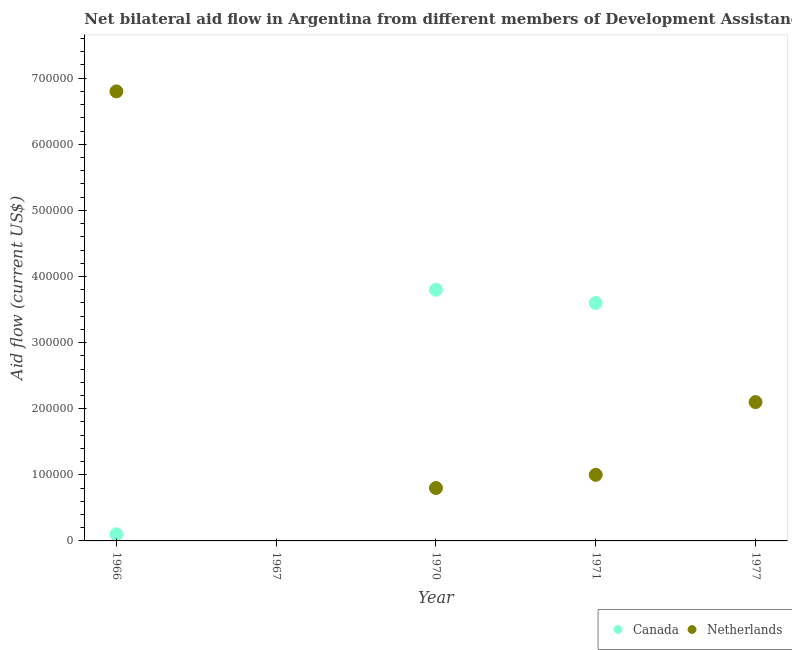How many different coloured dotlines are there?
Make the answer very short. 2. What is the amount of aid given by netherlands in 1971?
Keep it short and to the point. 1.00e+05. Across all years, what is the maximum amount of aid given by netherlands?
Your answer should be very brief. 6.80e+05. In which year was the amount of aid given by netherlands maximum?
Offer a terse response. 1966. What is the total amount of aid given by canada in the graph?
Your answer should be compact. 7.50e+05. What is the difference between the amount of aid given by canada in 1966 and that in 1971?
Your answer should be very brief. -3.50e+05. What is the difference between the amount of aid given by canada in 1966 and the amount of aid given by netherlands in 1977?
Keep it short and to the point. -2.00e+05. What is the average amount of aid given by netherlands per year?
Keep it short and to the point. 2.14e+05. In the year 1970, what is the difference between the amount of aid given by canada and amount of aid given by netherlands?
Give a very brief answer. 3.00e+05. In how many years, is the amount of aid given by canada greater than 500000 US$?
Keep it short and to the point. 0. What is the ratio of the amount of aid given by canada in 1966 to that in 1971?
Make the answer very short. 0.03. What is the difference between the highest and the second highest amount of aid given by netherlands?
Offer a terse response. 4.70e+05. What is the difference between the highest and the lowest amount of aid given by canada?
Make the answer very short. 3.80e+05. In how many years, is the amount of aid given by netherlands greater than the average amount of aid given by netherlands taken over all years?
Offer a very short reply. 1. Is the amount of aid given by canada strictly greater than the amount of aid given by netherlands over the years?
Your answer should be very brief. No. How many dotlines are there?
Provide a succinct answer. 2. How many years are there in the graph?
Offer a very short reply. 5. What is the difference between two consecutive major ticks on the Y-axis?
Offer a very short reply. 1.00e+05. Are the values on the major ticks of Y-axis written in scientific E-notation?
Make the answer very short. No. Does the graph contain any zero values?
Your answer should be compact. Yes. Does the graph contain grids?
Your answer should be compact. No. Where does the legend appear in the graph?
Your answer should be very brief. Bottom right. How are the legend labels stacked?
Provide a short and direct response. Horizontal. What is the title of the graph?
Your response must be concise. Net bilateral aid flow in Argentina from different members of Development Assistance Committee. What is the label or title of the X-axis?
Offer a very short reply. Year. What is the Aid flow (current US$) of Netherlands in 1966?
Provide a succinct answer. 6.80e+05. What is the Aid flow (current US$) in Canada in 1970?
Your response must be concise. 3.80e+05. What is the Aid flow (current US$) in Canada in 1977?
Keep it short and to the point. 0. Across all years, what is the maximum Aid flow (current US$) of Canada?
Provide a succinct answer. 3.80e+05. Across all years, what is the maximum Aid flow (current US$) of Netherlands?
Provide a short and direct response. 6.80e+05. What is the total Aid flow (current US$) of Canada in the graph?
Your answer should be compact. 7.50e+05. What is the total Aid flow (current US$) of Netherlands in the graph?
Provide a succinct answer. 1.07e+06. What is the difference between the Aid flow (current US$) in Canada in 1966 and that in 1970?
Ensure brevity in your answer.  -3.70e+05. What is the difference between the Aid flow (current US$) of Netherlands in 1966 and that in 1970?
Provide a short and direct response. 6.00e+05. What is the difference between the Aid flow (current US$) of Canada in 1966 and that in 1971?
Make the answer very short. -3.50e+05. What is the difference between the Aid flow (current US$) of Netherlands in 1966 and that in 1971?
Provide a short and direct response. 5.80e+05. What is the difference between the Aid flow (current US$) of Netherlands in 1970 and that in 1971?
Keep it short and to the point. -2.00e+04. What is the difference between the Aid flow (current US$) of Canada in 1970 and the Aid flow (current US$) of Netherlands in 1971?
Provide a short and direct response. 2.80e+05. What is the average Aid flow (current US$) of Netherlands per year?
Your response must be concise. 2.14e+05. In the year 1966, what is the difference between the Aid flow (current US$) of Canada and Aid flow (current US$) of Netherlands?
Your answer should be compact. -6.70e+05. In the year 1971, what is the difference between the Aid flow (current US$) in Canada and Aid flow (current US$) in Netherlands?
Give a very brief answer. 2.60e+05. What is the ratio of the Aid flow (current US$) in Canada in 1966 to that in 1970?
Make the answer very short. 0.03. What is the ratio of the Aid flow (current US$) of Netherlands in 1966 to that in 1970?
Provide a short and direct response. 8.5. What is the ratio of the Aid flow (current US$) of Canada in 1966 to that in 1971?
Offer a terse response. 0.03. What is the ratio of the Aid flow (current US$) in Netherlands in 1966 to that in 1977?
Give a very brief answer. 3.24. What is the ratio of the Aid flow (current US$) of Canada in 1970 to that in 1971?
Offer a very short reply. 1.06. What is the ratio of the Aid flow (current US$) in Netherlands in 1970 to that in 1977?
Your answer should be very brief. 0.38. What is the ratio of the Aid flow (current US$) in Netherlands in 1971 to that in 1977?
Your response must be concise. 0.48. What is the difference between the highest and the second highest Aid flow (current US$) of Canada?
Your answer should be very brief. 2.00e+04. What is the difference between the highest and the lowest Aid flow (current US$) in Netherlands?
Your answer should be very brief. 6.80e+05. 